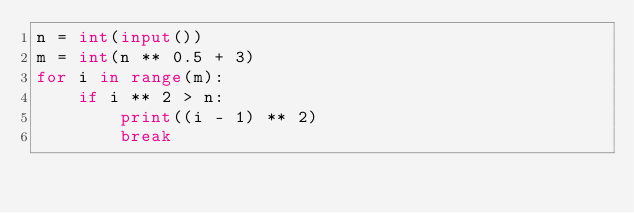<code> <loc_0><loc_0><loc_500><loc_500><_Python_>n = int(input())
m = int(n ** 0.5 + 3)
for i in range(m):
    if i ** 2 > n:
        print((i - 1) ** 2)
        break</code> 